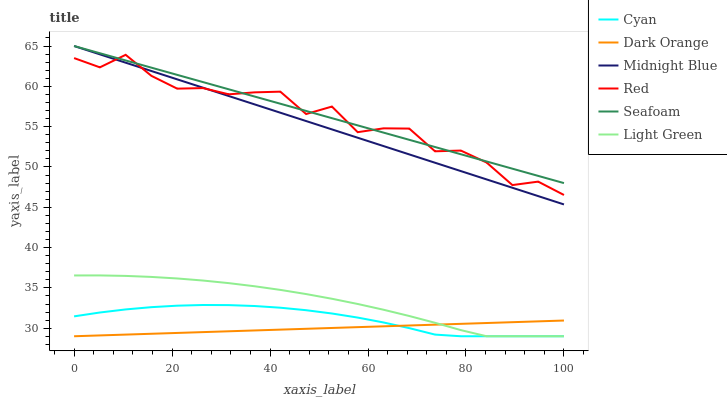Does Dark Orange have the minimum area under the curve?
Answer yes or no. Yes. Does Seafoam have the maximum area under the curve?
Answer yes or no. Yes. Does Midnight Blue have the minimum area under the curve?
Answer yes or no. No. Does Midnight Blue have the maximum area under the curve?
Answer yes or no. No. Is Dark Orange the smoothest?
Answer yes or no. Yes. Is Red the roughest?
Answer yes or no. Yes. Is Midnight Blue the smoothest?
Answer yes or no. No. Is Midnight Blue the roughest?
Answer yes or no. No. Does Dark Orange have the lowest value?
Answer yes or no. Yes. Does Midnight Blue have the lowest value?
Answer yes or no. No. Does Seafoam have the highest value?
Answer yes or no. Yes. Does Light Green have the highest value?
Answer yes or no. No. Is Light Green less than Midnight Blue?
Answer yes or no. Yes. Is Midnight Blue greater than Light Green?
Answer yes or no. Yes. Does Light Green intersect Dark Orange?
Answer yes or no. Yes. Is Light Green less than Dark Orange?
Answer yes or no. No. Is Light Green greater than Dark Orange?
Answer yes or no. No. Does Light Green intersect Midnight Blue?
Answer yes or no. No. 